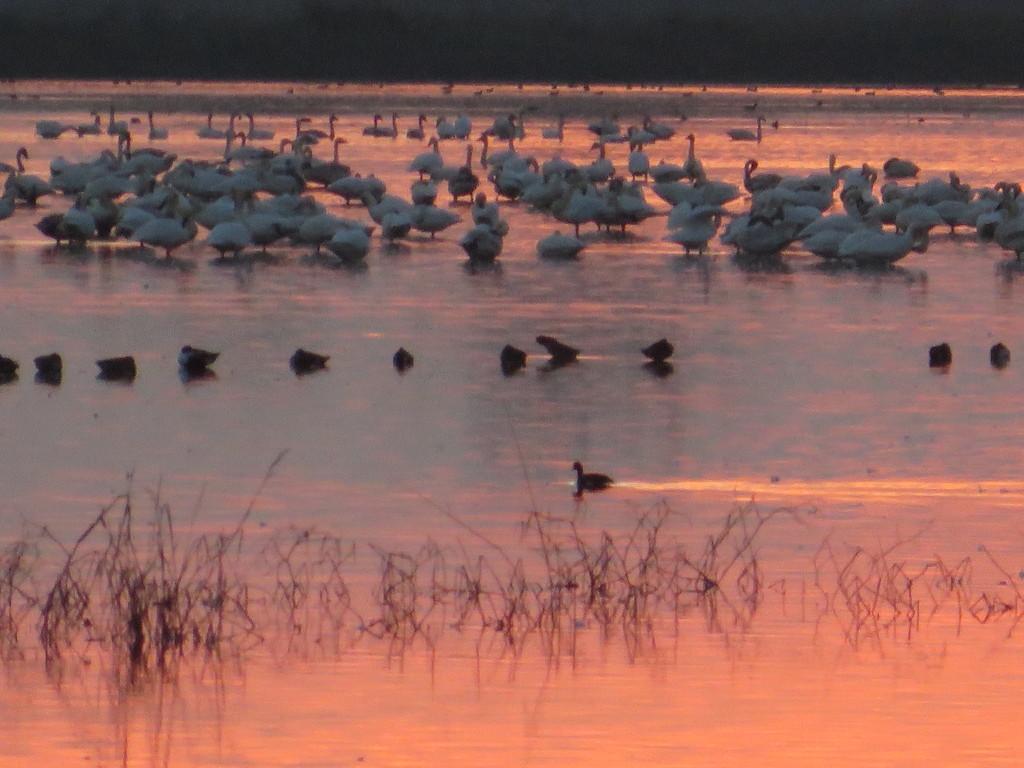Could you give a brief overview of what you see in this image? In this image I can see ground full of water and I can also see number of birds. On the bottom side of the image I can see stems. 